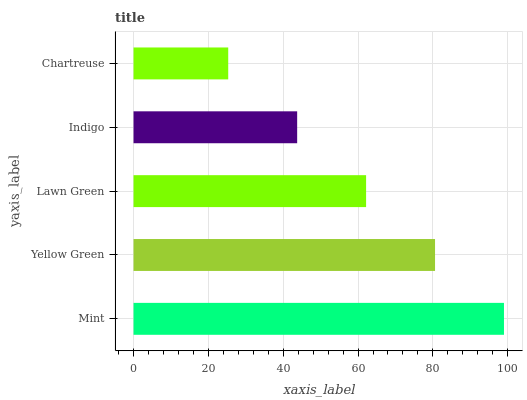Is Chartreuse the minimum?
Answer yes or no. Yes. Is Mint the maximum?
Answer yes or no. Yes. Is Yellow Green the minimum?
Answer yes or no. No. Is Yellow Green the maximum?
Answer yes or no. No. Is Mint greater than Yellow Green?
Answer yes or no. Yes. Is Yellow Green less than Mint?
Answer yes or no. Yes. Is Yellow Green greater than Mint?
Answer yes or no. No. Is Mint less than Yellow Green?
Answer yes or no. No. Is Lawn Green the high median?
Answer yes or no. Yes. Is Lawn Green the low median?
Answer yes or no. Yes. Is Indigo the high median?
Answer yes or no. No. Is Indigo the low median?
Answer yes or no. No. 